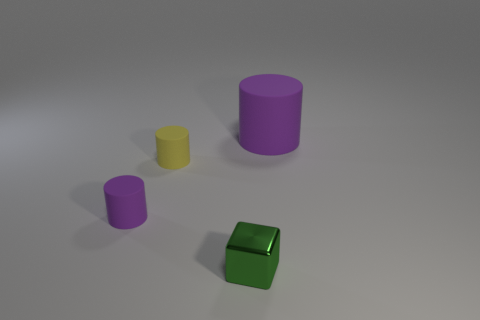How many objects are there in total, and can you describe their shapes and colors? There are four objects in the image. From left to right, we have a small yellow cylinder, a larger purple cylinder, another cylinder that’s smaller and purple, and a green metallic cube in the front. Each object is distinct with a solid color and a simple geometric shape. 